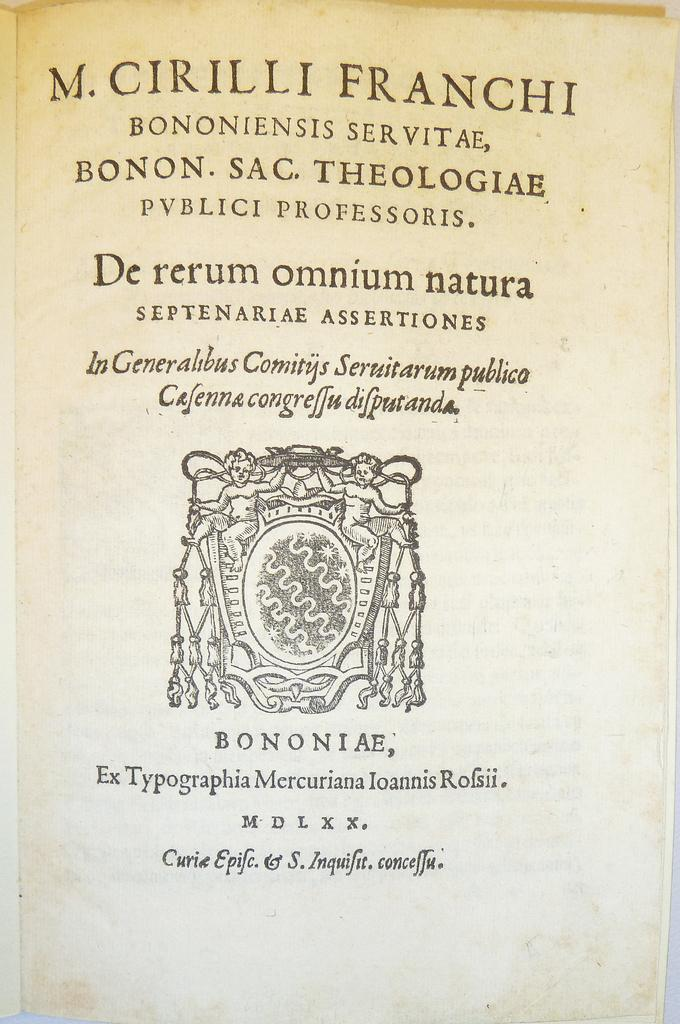<image>
Offer a succinct explanation of the picture presented. The title page of a book which first line reads "M. Cirili Franchi". 